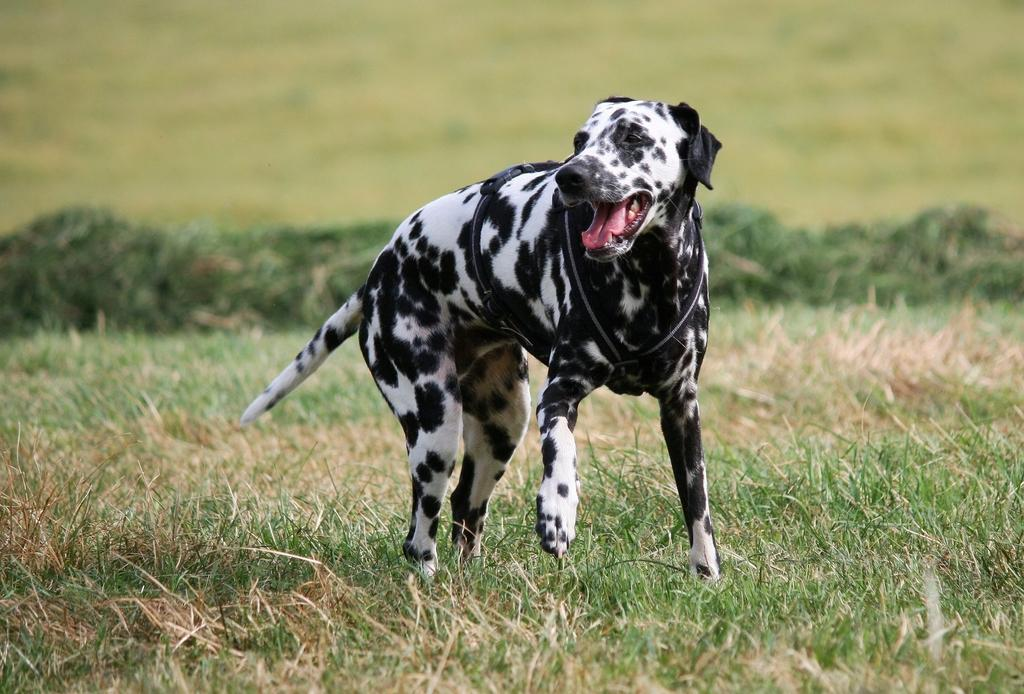What type of vegetation is present in the image? There is grass in the image. What is the main subject in the center of the image? There is a dog in the center of the image. What colors can be seen on the dog? The dog is white and black in color. How would you describe the background of the image? The background of the image is blurred. Can you see a cow using a brush on its body in the image? No, there is no cow or brush visible in the image. 